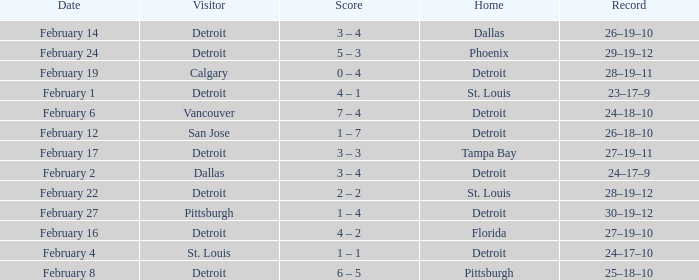What was their accomplishment during their time in pittsburgh? 25–18–10. 